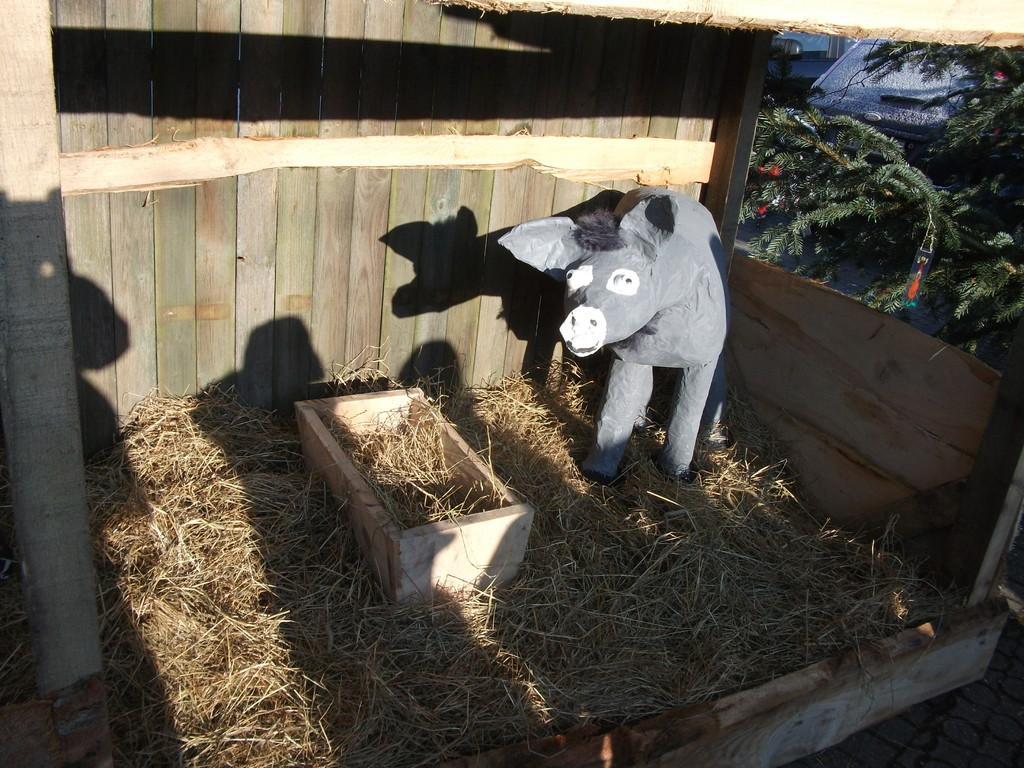Describe this image in one or two sentences. In this picture there is a small black color cow statue placed in the wooden box. On the bottom front side there is a dry straw and behind we can see the wooden panel wall and some trees. 